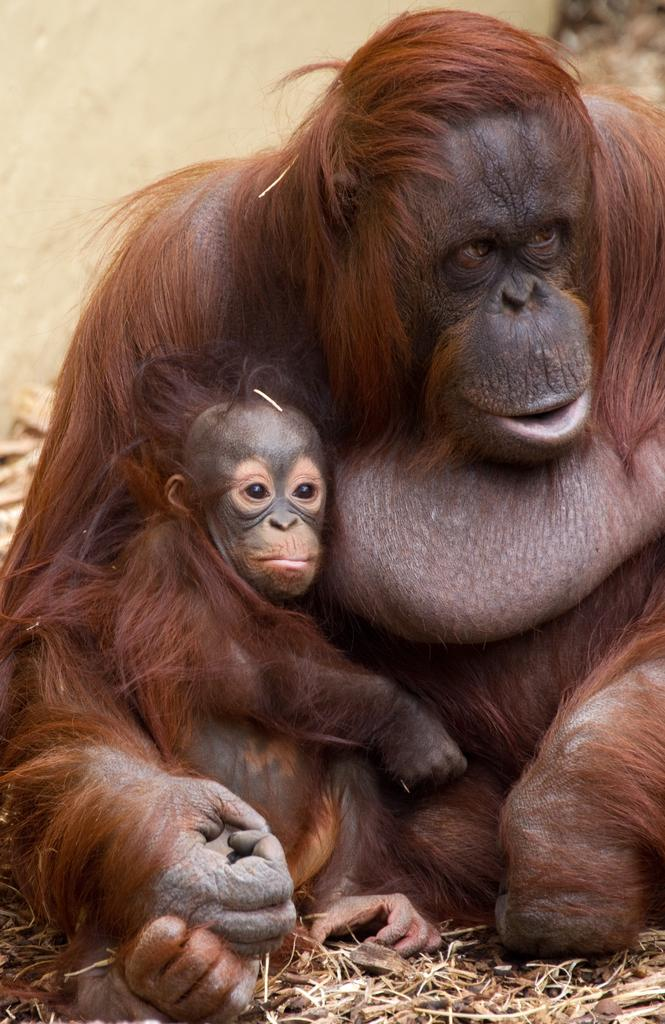What type of animal is in the image? There is an orangutan in the image. Where is the orangutan located? The orangutan is on the ground. What can be seen in the background of the image? There appears to be a stone in the background of the image. Reasoning: Let' Let's think step by step in order to produce the conversation. We start by identifying the main subject in the image, which is the orangutan. Then, we describe the orangutan's location, which is on the ground. Finally, we mention a detail about the background of the image, which is the presence of a stone. Each question is designed to elicit a specific detail about the image that is known from the provided facts. Absurd Question/Answer: What type of thread is being used by the orangutan in the image? There is no thread present in the image; it features an orangutan on the ground with a stone in the background. 